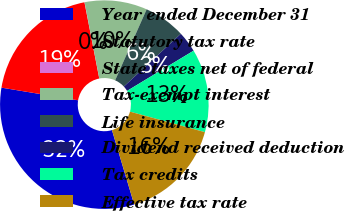Convert chart. <chart><loc_0><loc_0><loc_500><loc_500><pie_chart><fcel>Year ended December 31<fcel>Statutory tax rate<fcel>State taxes net of federal<fcel>Tax-exempt interest<fcel>Life insurance<fcel>Dividend received deduction<fcel>Tax credits<fcel>Effective tax rate<nl><fcel>32.23%<fcel>19.34%<fcel>0.02%<fcel>9.68%<fcel>6.46%<fcel>3.24%<fcel>12.9%<fcel>16.12%<nl></chart> 